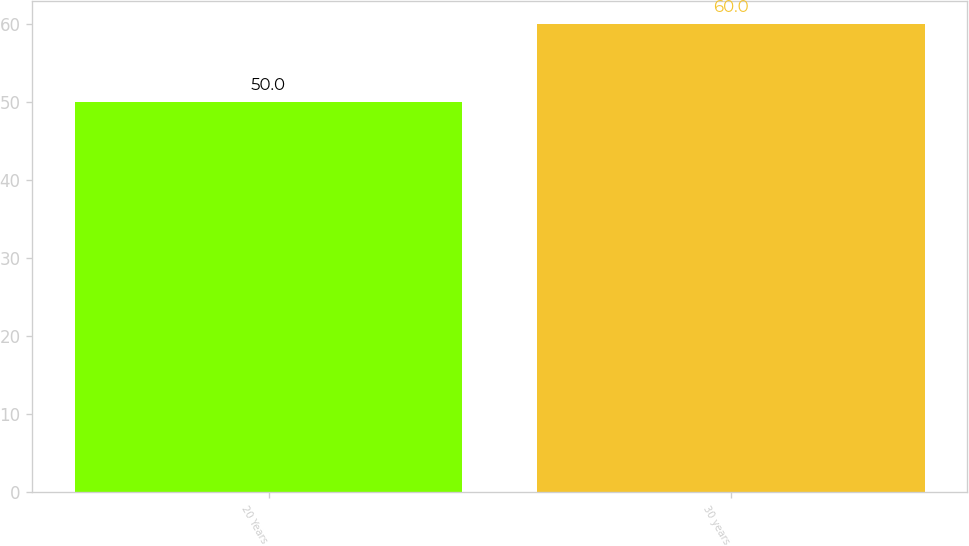Convert chart to OTSL. <chart><loc_0><loc_0><loc_500><loc_500><bar_chart><fcel>20 Years<fcel>30 years<nl><fcel>50<fcel>60<nl></chart> 